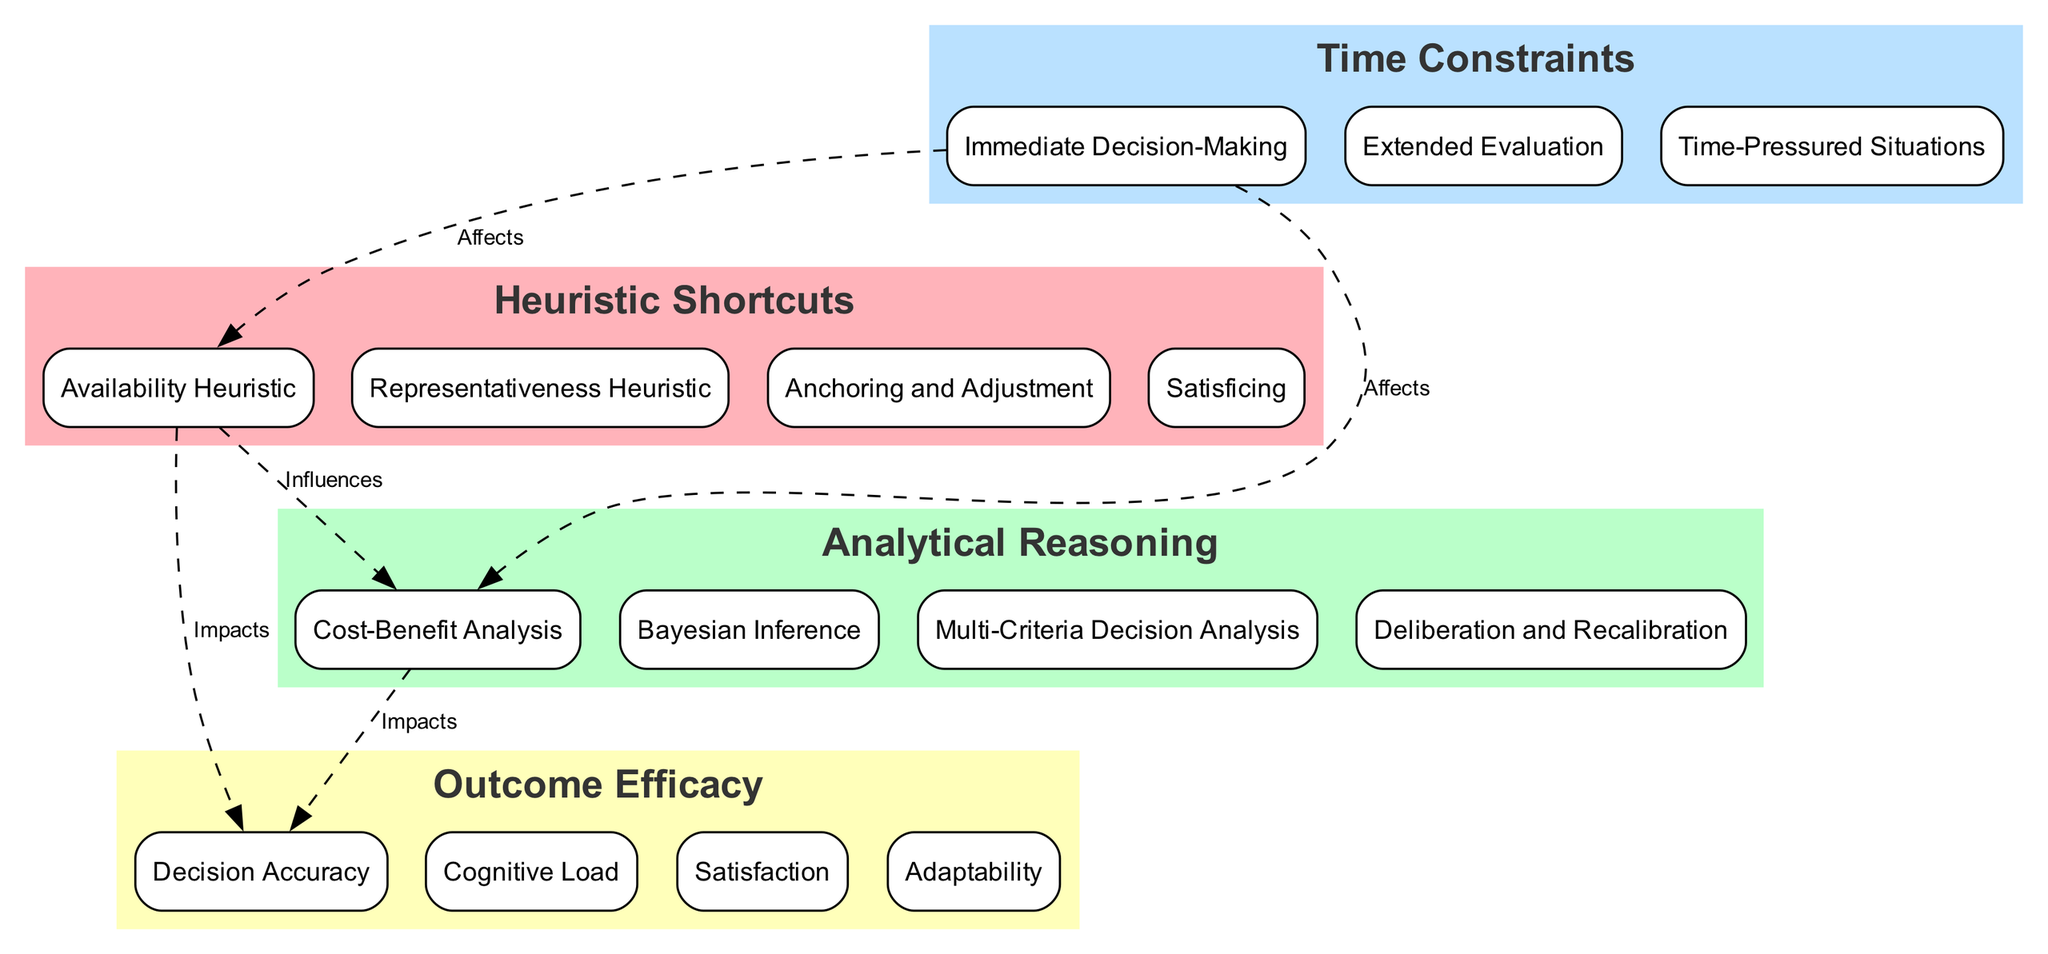What are the components of the Heuristic Shortcuts block? The Heuristic Shortcuts block contains four components: Availability Heuristic, Representativeness Heuristic, Anchoring and Adjustment, and Satisficing.
Answer: Availability Heuristic, Representativeness Heuristic, Anchoring and Adjustment, Satisficing How many components are in the Analytical Reasoning block? The Analytical Reasoning block includes four components: Cost-Benefit Analysis, Bayesian Inference, Multi-Criteria Decision Analysis, and Deliberation and Recalibration. Therefore, the total is four.
Answer: 4 What type of influence is shown between Heuristic Shortcuts and Analytical Reasoning? The diagram indicates that Heuristic Shortcuts has an 'Influences' relationship with Analytical Reasoning.
Answer: Influences Which block has a component related to 'Immediate Decision-Making'? The block that contains 'Immediate Decision-Making' is the Time Constraints block.
Answer: Time Constraints What are the relationship effects of Time Constraints on both Heuristic Shortcuts and Analytical Reasoning? The diagram illustrates that Time Constraints 'Affects' both the Heuristic Shortcuts and Analytical Reasoning blocks, highlighting how time influences decision-making processes in both areas.
Answer: Affects Which component in the Outcome Efficacy block is related to mental effort? The component that addresses mental effort is Cognitive Load within the Outcome Efficacy block.
Answer: Cognitive Load Which block impacts the outcome efficacy of decisions made using Heuristic Shortcuts? The Outcome Efficacy block directly receives an 'Impacts' relationship from the Heuristic Shortcuts block, showcasing its effect on how effective these decisions are.
Answer: Outcome Efficacy How many edges are present in the diagram? The diagram has five edges connecting various blocks, demonstrating the relationships between them.
Answer: 5 What type of decision-making is most likely to occur with time constraints? The type of decision-making most likely to occur under time constraints is Immediate Decision-Making, which relies more on heuristics.
Answer: Immediate Decision-Making 